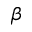Convert formula to latex. <formula><loc_0><loc_0><loc_500><loc_500>\beta</formula> 